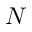<formula> <loc_0><loc_0><loc_500><loc_500>N</formula> 